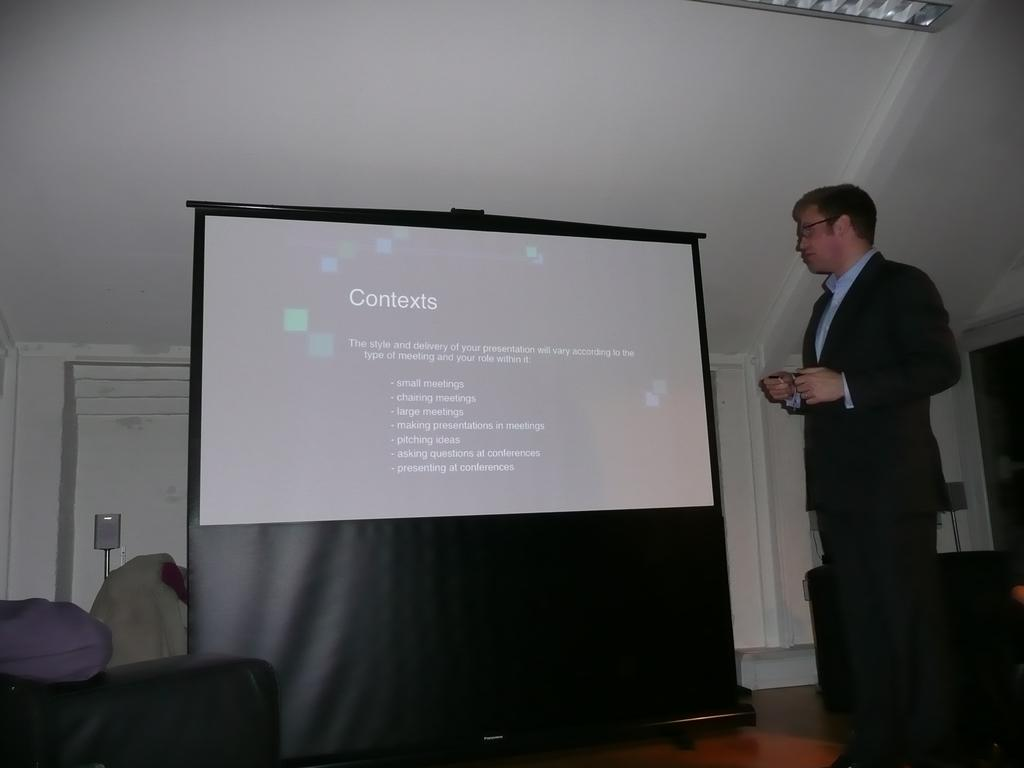What is present in the image along with the person? There is a screen with text beside the person. What type of furniture can be seen in the image? There are couches in the image. What can be seen illuminating the area in the image? There are lights in the image. What type of structure is present in the image? There is a wall and a roof in the image. What type of trousers is the family wearing in the image? There is no family present in the image, and therefore no one is wearing trousers. What is the value of the item on the wall in the image? There is no item on the wall in the image that has a value associated with it. 